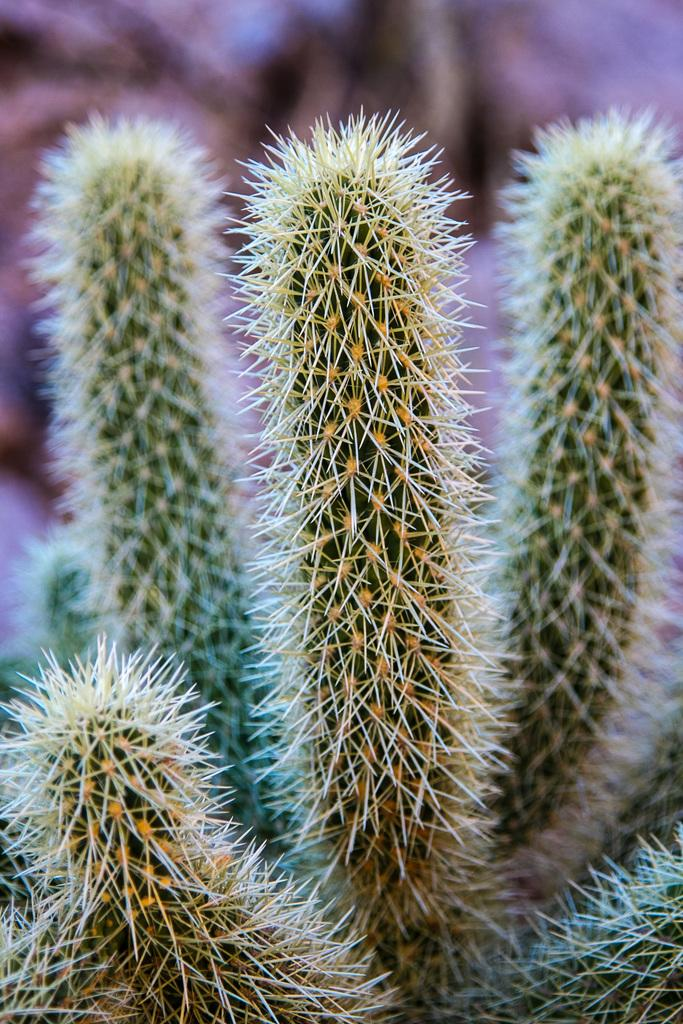What type of living organisms can be seen in the image? Plants can be seen in the image. Can you describe the background of the image? The background of the image is blurred. Who is the owner of the shock in the image? There is no shock or owner mentioned in the image, as it only features plants and a blurred background. 